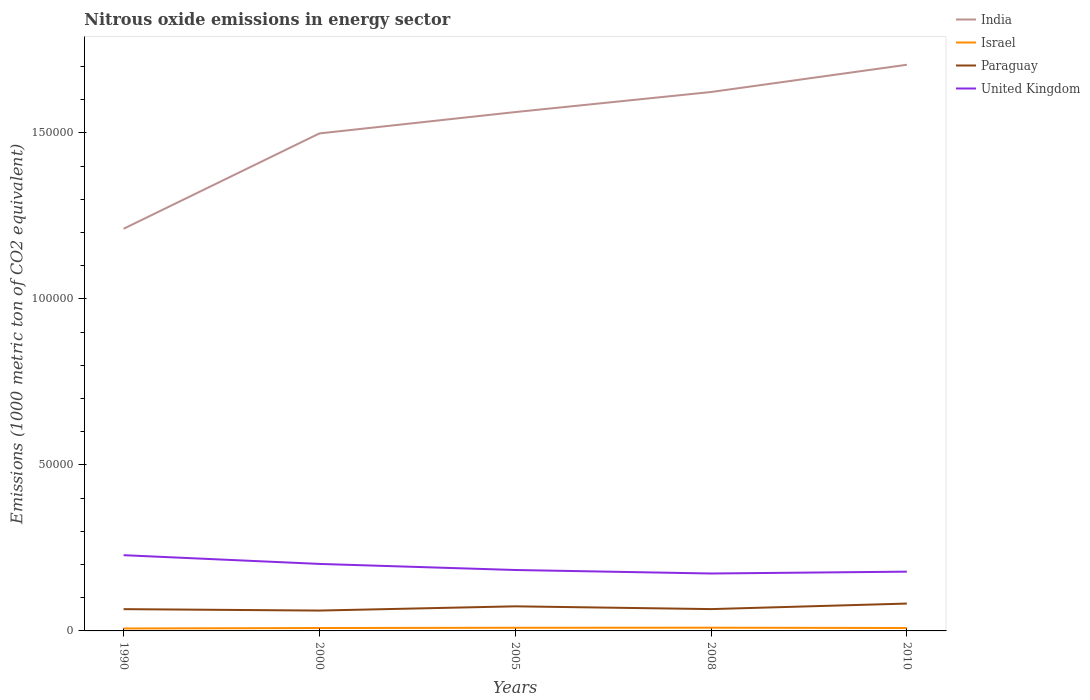Is the number of lines equal to the number of legend labels?
Your answer should be compact. Yes. Across all years, what is the maximum amount of nitrous oxide emitted in United Kingdom?
Ensure brevity in your answer.  1.73e+04. What is the total amount of nitrous oxide emitted in United Kingdom in the graph?
Offer a very short reply. 2887.8. What is the difference between the highest and the second highest amount of nitrous oxide emitted in Israel?
Offer a very short reply. 235.7. What is the difference between the highest and the lowest amount of nitrous oxide emitted in Israel?
Keep it short and to the point. 2. How many years are there in the graph?
Give a very brief answer. 5. Are the values on the major ticks of Y-axis written in scientific E-notation?
Your response must be concise. No. Does the graph contain any zero values?
Provide a succinct answer. No. Does the graph contain grids?
Your answer should be compact. No. How many legend labels are there?
Your answer should be compact. 4. What is the title of the graph?
Your response must be concise. Nitrous oxide emissions in energy sector. Does "Sweden" appear as one of the legend labels in the graph?
Your response must be concise. No. What is the label or title of the X-axis?
Keep it short and to the point. Years. What is the label or title of the Y-axis?
Ensure brevity in your answer.  Emissions (1000 metric ton of CO2 equivalent). What is the Emissions (1000 metric ton of CO2 equivalent) of India in 1990?
Ensure brevity in your answer.  1.21e+05. What is the Emissions (1000 metric ton of CO2 equivalent) of Israel in 1990?
Provide a succinct answer. 733.2. What is the Emissions (1000 metric ton of CO2 equivalent) in Paraguay in 1990?
Offer a terse response. 6561.2. What is the Emissions (1000 metric ton of CO2 equivalent) in United Kingdom in 1990?
Your response must be concise. 2.28e+04. What is the Emissions (1000 metric ton of CO2 equivalent) of India in 2000?
Your answer should be compact. 1.50e+05. What is the Emissions (1000 metric ton of CO2 equivalent) of Israel in 2000?
Keep it short and to the point. 875.7. What is the Emissions (1000 metric ton of CO2 equivalent) in Paraguay in 2000?
Your response must be concise. 6132.8. What is the Emissions (1000 metric ton of CO2 equivalent) in United Kingdom in 2000?
Your answer should be very brief. 2.02e+04. What is the Emissions (1000 metric ton of CO2 equivalent) in India in 2005?
Your answer should be compact. 1.56e+05. What is the Emissions (1000 metric ton of CO2 equivalent) in Israel in 2005?
Provide a succinct answer. 949.9. What is the Emissions (1000 metric ton of CO2 equivalent) of Paraguay in 2005?
Keep it short and to the point. 7407.7. What is the Emissions (1000 metric ton of CO2 equivalent) in United Kingdom in 2005?
Provide a short and direct response. 1.84e+04. What is the Emissions (1000 metric ton of CO2 equivalent) in India in 2008?
Ensure brevity in your answer.  1.62e+05. What is the Emissions (1000 metric ton of CO2 equivalent) in Israel in 2008?
Ensure brevity in your answer.  968.9. What is the Emissions (1000 metric ton of CO2 equivalent) of Paraguay in 2008?
Provide a succinct answer. 6573. What is the Emissions (1000 metric ton of CO2 equivalent) in United Kingdom in 2008?
Provide a succinct answer. 1.73e+04. What is the Emissions (1000 metric ton of CO2 equivalent) of India in 2010?
Ensure brevity in your answer.  1.71e+05. What is the Emissions (1000 metric ton of CO2 equivalent) in Israel in 2010?
Offer a very short reply. 881.8. What is the Emissions (1000 metric ton of CO2 equivalent) of Paraguay in 2010?
Your response must be concise. 8239.6. What is the Emissions (1000 metric ton of CO2 equivalent) in United Kingdom in 2010?
Provide a succinct answer. 1.79e+04. Across all years, what is the maximum Emissions (1000 metric ton of CO2 equivalent) of India?
Your answer should be compact. 1.71e+05. Across all years, what is the maximum Emissions (1000 metric ton of CO2 equivalent) of Israel?
Give a very brief answer. 968.9. Across all years, what is the maximum Emissions (1000 metric ton of CO2 equivalent) of Paraguay?
Provide a short and direct response. 8239.6. Across all years, what is the maximum Emissions (1000 metric ton of CO2 equivalent) of United Kingdom?
Your response must be concise. 2.28e+04. Across all years, what is the minimum Emissions (1000 metric ton of CO2 equivalent) in India?
Your answer should be very brief. 1.21e+05. Across all years, what is the minimum Emissions (1000 metric ton of CO2 equivalent) in Israel?
Ensure brevity in your answer.  733.2. Across all years, what is the minimum Emissions (1000 metric ton of CO2 equivalent) in Paraguay?
Keep it short and to the point. 6132.8. Across all years, what is the minimum Emissions (1000 metric ton of CO2 equivalent) in United Kingdom?
Your answer should be compact. 1.73e+04. What is the total Emissions (1000 metric ton of CO2 equivalent) in India in the graph?
Your answer should be very brief. 7.60e+05. What is the total Emissions (1000 metric ton of CO2 equivalent) in Israel in the graph?
Offer a terse response. 4409.5. What is the total Emissions (1000 metric ton of CO2 equivalent) in Paraguay in the graph?
Your response must be concise. 3.49e+04. What is the total Emissions (1000 metric ton of CO2 equivalent) of United Kingdom in the graph?
Offer a very short reply. 9.65e+04. What is the difference between the Emissions (1000 metric ton of CO2 equivalent) in India in 1990 and that in 2000?
Offer a very short reply. -2.87e+04. What is the difference between the Emissions (1000 metric ton of CO2 equivalent) in Israel in 1990 and that in 2000?
Ensure brevity in your answer.  -142.5. What is the difference between the Emissions (1000 metric ton of CO2 equivalent) in Paraguay in 1990 and that in 2000?
Offer a very short reply. 428.4. What is the difference between the Emissions (1000 metric ton of CO2 equivalent) in United Kingdom in 1990 and that in 2000?
Offer a terse response. 2628.9. What is the difference between the Emissions (1000 metric ton of CO2 equivalent) of India in 1990 and that in 2005?
Provide a succinct answer. -3.51e+04. What is the difference between the Emissions (1000 metric ton of CO2 equivalent) of Israel in 1990 and that in 2005?
Provide a short and direct response. -216.7. What is the difference between the Emissions (1000 metric ton of CO2 equivalent) in Paraguay in 1990 and that in 2005?
Keep it short and to the point. -846.5. What is the difference between the Emissions (1000 metric ton of CO2 equivalent) of United Kingdom in 1990 and that in 2005?
Ensure brevity in your answer.  4460.9. What is the difference between the Emissions (1000 metric ton of CO2 equivalent) in India in 1990 and that in 2008?
Make the answer very short. -4.12e+04. What is the difference between the Emissions (1000 metric ton of CO2 equivalent) in Israel in 1990 and that in 2008?
Your response must be concise. -235.7. What is the difference between the Emissions (1000 metric ton of CO2 equivalent) of United Kingdom in 1990 and that in 2008?
Your answer should be compact. 5516.7. What is the difference between the Emissions (1000 metric ton of CO2 equivalent) of India in 1990 and that in 2010?
Ensure brevity in your answer.  -4.94e+04. What is the difference between the Emissions (1000 metric ton of CO2 equivalent) of Israel in 1990 and that in 2010?
Keep it short and to the point. -148.6. What is the difference between the Emissions (1000 metric ton of CO2 equivalent) of Paraguay in 1990 and that in 2010?
Give a very brief answer. -1678.4. What is the difference between the Emissions (1000 metric ton of CO2 equivalent) in United Kingdom in 1990 and that in 2010?
Ensure brevity in your answer.  4962.2. What is the difference between the Emissions (1000 metric ton of CO2 equivalent) in India in 2000 and that in 2005?
Offer a very short reply. -6428.4. What is the difference between the Emissions (1000 metric ton of CO2 equivalent) of Israel in 2000 and that in 2005?
Provide a succinct answer. -74.2. What is the difference between the Emissions (1000 metric ton of CO2 equivalent) in Paraguay in 2000 and that in 2005?
Keep it short and to the point. -1274.9. What is the difference between the Emissions (1000 metric ton of CO2 equivalent) in United Kingdom in 2000 and that in 2005?
Your answer should be very brief. 1832. What is the difference between the Emissions (1000 metric ton of CO2 equivalent) of India in 2000 and that in 2008?
Provide a short and direct response. -1.25e+04. What is the difference between the Emissions (1000 metric ton of CO2 equivalent) of Israel in 2000 and that in 2008?
Provide a short and direct response. -93.2. What is the difference between the Emissions (1000 metric ton of CO2 equivalent) in Paraguay in 2000 and that in 2008?
Keep it short and to the point. -440.2. What is the difference between the Emissions (1000 metric ton of CO2 equivalent) of United Kingdom in 2000 and that in 2008?
Ensure brevity in your answer.  2887.8. What is the difference between the Emissions (1000 metric ton of CO2 equivalent) in India in 2000 and that in 2010?
Provide a short and direct response. -2.07e+04. What is the difference between the Emissions (1000 metric ton of CO2 equivalent) of Paraguay in 2000 and that in 2010?
Keep it short and to the point. -2106.8. What is the difference between the Emissions (1000 metric ton of CO2 equivalent) of United Kingdom in 2000 and that in 2010?
Give a very brief answer. 2333.3. What is the difference between the Emissions (1000 metric ton of CO2 equivalent) in India in 2005 and that in 2008?
Offer a very short reply. -6044.2. What is the difference between the Emissions (1000 metric ton of CO2 equivalent) in Paraguay in 2005 and that in 2008?
Your response must be concise. 834.7. What is the difference between the Emissions (1000 metric ton of CO2 equivalent) in United Kingdom in 2005 and that in 2008?
Keep it short and to the point. 1055.8. What is the difference between the Emissions (1000 metric ton of CO2 equivalent) in India in 2005 and that in 2010?
Make the answer very short. -1.43e+04. What is the difference between the Emissions (1000 metric ton of CO2 equivalent) in Israel in 2005 and that in 2010?
Your answer should be very brief. 68.1. What is the difference between the Emissions (1000 metric ton of CO2 equivalent) of Paraguay in 2005 and that in 2010?
Provide a succinct answer. -831.9. What is the difference between the Emissions (1000 metric ton of CO2 equivalent) in United Kingdom in 2005 and that in 2010?
Offer a very short reply. 501.3. What is the difference between the Emissions (1000 metric ton of CO2 equivalent) in India in 2008 and that in 2010?
Provide a short and direct response. -8207.6. What is the difference between the Emissions (1000 metric ton of CO2 equivalent) of Israel in 2008 and that in 2010?
Give a very brief answer. 87.1. What is the difference between the Emissions (1000 metric ton of CO2 equivalent) in Paraguay in 2008 and that in 2010?
Make the answer very short. -1666.6. What is the difference between the Emissions (1000 metric ton of CO2 equivalent) of United Kingdom in 2008 and that in 2010?
Keep it short and to the point. -554.5. What is the difference between the Emissions (1000 metric ton of CO2 equivalent) in India in 1990 and the Emissions (1000 metric ton of CO2 equivalent) in Israel in 2000?
Offer a very short reply. 1.20e+05. What is the difference between the Emissions (1000 metric ton of CO2 equivalent) in India in 1990 and the Emissions (1000 metric ton of CO2 equivalent) in Paraguay in 2000?
Your response must be concise. 1.15e+05. What is the difference between the Emissions (1000 metric ton of CO2 equivalent) of India in 1990 and the Emissions (1000 metric ton of CO2 equivalent) of United Kingdom in 2000?
Give a very brief answer. 1.01e+05. What is the difference between the Emissions (1000 metric ton of CO2 equivalent) of Israel in 1990 and the Emissions (1000 metric ton of CO2 equivalent) of Paraguay in 2000?
Your response must be concise. -5399.6. What is the difference between the Emissions (1000 metric ton of CO2 equivalent) in Israel in 1990 and the Emissions (1000 metric ton of CO2 equivalent) in United Kingdom in 2000?
Provide a short and direct response. -1.95e+04. What is the difference between the Emissions (1000 metric ton of CO2 equivalent) of Paraguay in 1990 and the Emissions (1000 metric ton of CO2 equivalent) of United Kingdom in 2000?
Provide a succinct answer. -1.36e+04. What is the difference between the Emissions (1000 metric ton of CO2 equivalent) in India in 1990 and the Emissions (1000 metric ton of CO2 equivalent) in Israel in 2005?
Your answer should be compact. 1.20e+05. What is the difference between the Emissions (1000 metric ton of CO2 equivalent) in India in 1990 and the Emissions (1000 metric ton of CO2 equivalent) in Paraguay in 2005?
Your answer should be very brief. 1.14e+05. What is the difference between the Emissions (1000 metric ton of CO2 equivalent) of India in 1990 and the Emissions (1000 metric ton of CO2 equivalent) of United Kingdom in 2005?
Your answer should be very brief. 1.03e+05. What is the difference between the Emissions (1000 metric ton of CO2 equivalent) in Israel in 1990 and the Emissions (1000 metric ton of CO2 equivalent) in Paraguay in 2005?
Offer a very short reply. -6674.5. What is the difference between the Emissions (1000 metric ton of CO2 equivalent) of Israel in 1990 and the Emissions (1000 metric ton of CO2 equivalent) of United Kingdom in 2005?
Your answer should be compact. -1.76e+04. What is the difference between the Emissions (1000 metric ton of CO2 equivalent) in Paraguay in 1990 and the Emissions (1000 metric ton of CO2 equivalent) in United Kingdom in 2005?
Offer a terse response. -1.18e+04. What is the difference between the Emissions (1000 metric ton of CO2 equivalent) in India in 1990 and the Emissions (1000 metric ton of CO2 equivalent) in Israel in 2008?
Provide a short and direct response. 1.20e+05. What is the difference between the Emissions (1000 metric ton of CO2 equivalent) in India in 1990 and the Emissions (1000 metric ton of CO2 equivalent) in Paraguay in 2008?
Your response must be concise. 1.15e+05. What is the difference between the Emissions (1000 metric ton of CO2 equivalent) in India in 1990 and the Emissions (1000 metric ton of CO2 equivalent) in United Kingdom in 2008?
Your answer should be very brief. 1.04e+05. What is the difference between the Emissions (1000 metric ton of CO2 equivalent) in Israel in 1990 and the Emissions (1000 metric ton of CO2 equivalent) in Paraguay in 2008?
Keep it short and to the point. -5839.8. What is the difference between the Emissions (1000 metric ton of CO2 equivalent) of Israel in 1990 and the Emissions (1000 metric ton of CO2 equivalent) of United Kingdom in 2008?
Make the answer very short. -1.66e+04. What is the difference between the Emissions (1000 metric ton of CO2 equivalent) of Paraguay in 1990 and the Emissions (1000 metric ton of CO2 equivalent) of United Kingdom in 2008?
Ensure brevity in your answer.  -1.07e+04. What is the difference between the Emissions (1000 metric ton of CO2 equivalent) of India in 1990 and the Emissions (1000 metric ton of CO2 equivalent) of Israel in 2010?
Your response must be concise. 1.20e+05. What is the difference between the Emissions (1000 metric ton of CO2 equivalent) of India in 1990 and the Emissions (1000 metric ton of CO2 equivalent) of Paraguay in 2010?
Provide a succinct answer. 1.13e+05. What is the difference between the Emissions (1000 metric ton of CO2 equivalent) of India in 1990 and the Emissions (1000 metric ton of CO2 equivalent) of United Kingdom in 2010?
Provide a succinct answer. 1.03e+05. What is the difference between the Emissions (1000 metric ton of CO2 equivalent) in Israel in 1990 and the Emissions (1000 metric ton of CO2 equivalent) in Paraguay in 2010?
Provide a short and direct response. -7506.4. What is the difference between the Emissions (1000 metric ton of CO2 equivalent) in Israel in 1990 and the Emissions (1000 metric ton of CO2 equivalent) in United Kingdom in 2010?
Your answer should be compact. -1.71e+04. What is the difference between the Emissions (1000 metric ton of CO2 equivalent) of Paraguay in 1990 and the Emissions (1000 metric ton of CO2 equivalent) of United Kingdom in 2010?
Your answer should be very brief. -1.13e+04. What is the difference between the Emissions (1000 metric ton of CO2 equivalent) of India in 2000 and the Emissions (1000 metric ton of CO2 equivalent) of Israel in 2005?
Your response must be concise. 1.49e+05. What is the difference between the Emissions (1000 metric ton of CO2 equivalent) of India in 2000 and the Emissions (1000 metric ton of CO2 equivalent) of Paraguay in 2005?
Make the answer very short. 1.42e+05. What is the difference between the Emissions (1000 metric ton of CO2 equivalent) in India in 2000 and the Emissions (1000 metric ton of CO2 equivalent) in United Kingdom in 2005?
Keep it short and to the point. 1.32e+05. What is the difference between the Emissions (1000 metric ton of CO2 equivalent) in Israel in 2000 and the Emissions (1000 metric ton of CO2 equivalent) in Paraguay in 2005?
Ensure brevity in your answer.  -6532. What is the difference between the Emissions (1000 metric ton of CO2 equivalent) in Israel in 2000 and the Emissions (1000 metric ton of CO2 equivalent) in United Kingdom in 2005?
Your answer should be compact. -1.75e+04. What is the difference between the Emissions (1000 metric ton of CO2 equivalent) of Paraguay in 2000 and the Emissions (1000 metric ton of CO2 equivalent) of United Kingdom in 2005?
Provide a succinct answer. -1.22e+04. What is the difference between the Emissions (1000 metric ton of CO2 equivalent) of India in 2000 and the Emissions (1000 metric ton of CO2 equivalent) of Israel in 2008?
Your answer should be compact. 1.49e+05. What is the difference between the Emissions (1000 metric ton of CO2 equivalent) of India in 2000 and the Emissions (1000 metric ton of CO2 equivalent) of Paraguay in 2008?
Offer a terse response. 1.43e+05. What is the difference between the Emissions (1000 metric ton of CO2 equivalent) in India in 2000 and the Emissions (1000 metric ton of CO2 equivalent) in United Kingdom in 2008?
Your response must be concise. 1.33e+05. What is the difference between the Emissions (1000 metric ton of CO2 equivalent) in Israel in 2000 and the Emissions (1000 metric ton of CO2 equivalent) in Paraguay in 2008?
Your response must be concise. -5697.3. What is the difference between the Emissions (1000 metric ton of CO2 equivalent) in Israel in 2000 and the Emissions (1000 metric ton of CO2 equivalent) in United Kingdom in 2008?
Provide a succinct answer. -1.64e+04. What is the difference between the Emissions (1000 metric ton of CO2 equivalent) in Paraguay in 2000 and the Emissions (1000 metric ton of CO2 equivalent) in United Kingdom in 2008?
Your response must be concise. -1.12e+04. What is the difference between the Emissions (1000 metric ton of CO2 equivalent) of India in 2000 and the Emissions (1000 metric ton of CO2 equivalent) of Israel in 2010?
Your response must be concise. 1.49e+05. What is the difference between the Emissions (1000 metric ton of CO2 equivalent) of India in 2000 and the Emissions (1000 metric ton of CO2 equivalent) of Paraguay in 2010?
Keep it short and to the point. 1.42e+05. What is the difference between the Emissions (1000 metric ton of CO2 equivalent) in India in 2000 and the Emissions (1000 metric ton of CO2 equivalent) in United Kingdom in 2010?
Your answer should be very brief. 1.32e+05. What is the difference between the Emissions (1000 metric ton of CO2 equivalent) of Israel in 2000 and the Emissions (1000 metric ton of CO2 equivalent) of Paraguay in 2010?
Offer a very short reply. -7363.9. What is the difference between the Emissions (1000 metric ton of CO2 equivalent) in Israel in 2000 and the Emissions (1000 metric ton of CO2 equivalent) in United Kingdom in 2010?
Provide a succinct answer. -1.70e+04. What is the difference between the Emissions (1000 metric ton of CO2 equivalent) in Paraguay in 2000 and the Emissions (1000 metric ton of CO2 equivalent) in United Kingdom in 2010?
Keep it short and to the point. -1.17e+04. What is the difference between the Emissions (1000 metric ton of CO2 equivalent) in India in 2005 and the Emissions (1000 metric ton of CO2 equivalent) in Israel in 2008?
Your answer should be very brief. 1.55e+05. What is the difference between the Emissions (1000 metric ton of CO2 equivalent) of India in 2005 and the Emissions (1000 metric ton of CO2 equivalent) of Paraguay in 2008?
Your answer should be compact. 1.50e+05. What is the difference between the Emissions (1000 metric ton of CO2 equivalent) in India in 2005 and the Emissions (1000 metric ton of CO2 equivalent) in United Kingdom in 2008?
Your response must be concise. 1.39e+05. What is the difference between the Emissions (1000 metric ton of CO2 equivalent) of Israel in 2005 and the Emissions (1000 metric ton of CO2 equivalent) of Paraguay in 2008?
Keep it short and to the point. -5623.1. What is the difference between the Emissions (1000 metric ton of CO2 equivalent) of Israel in 2005 and the Emissions (1000 metric ton of CO2 equivalent) of United Kingdom in 2008?
Make the answer very short. -1.63e+04. What is the difference between the Emissions (1000 metric ton of CO2 equivalent) of Paraguay in 2005 and the Emissions (1000 metric ton of CO2 equivalent) of United Kingdom in 2008?
Make the answer very short. -9889.5. What is the difference between the Emissions (1000 metric ton of CO2 equivalent) of India in 2005 and the Emissions (1000 metric ton of CO2 equivalent) of Israel in 2010?
Your answer should be very brief. 1.55e+05. What is the difference between the Emissions (1000 metric ton of CO2 equivalent) in India in 2005 and the Emissions (1000 metric ton of CO2 equivalent) in Paraguay in 2010?
Provide a succinct answer. 1.48e+05. What is the difference between the Emissions (1000 metric ton of CO2 equivalent) of India in 2005 and the Emissions (1000 metric ton of CO2 equivalent) of United Kingdom in 2010?
Your answer should be compact. 1.38e+05. What is the difference between the Emissions (1000 metric ton of CO2 equivalent) in Israel in 2005 and the Emissions (1000 metric ton of CO2 equivalent) in Paraguay in 2010?
Provide a succinct answer. -7289.7. What is the difference between the Emissions (1000 metric ton of CO2 equivalent) in Israel in 2005 and the Emissions (1000 metric ton of CO2 equivalent) in United Kingdom in 2010?
Give a very brief answer. -1.69e+04. What is the difference between the Emissions (1000 metric ton of CO2 equivalent) of Paraguay in 2005 and the Emissions (1000 metric ton of CO2 equivalent) of United Kingdom in 2010?
Your answer should be compact. -1.04e+04. What is the difference between the Emissions (1000 metric ton of CO2 equivalent) in India in 2008 and the Emissions (1000 metric ton of CO2 equivalent) in Israel in 2010?
Ensure brevity in your answer.  1.61e+05. What is the difference between the Emissions (1000 metric ton of CO2 equivalent) in India in 2008 and the Emissions (1000 metric ton of CO2 equivalent) in Paraguay in 2010?
Ensure brevity in your answer.  1.54e+05. What is the difference between the Emissions (1000 metric ton of CO2 equivalent) in India in 2008 and the Emissions (1000 metric ton of CO2 equivalent) in United Kingdom in 2010?
Your response must be concise. 1.44e+05. What is the difference between the Emissions (1000 metric ton of CO2 equivalent) of Israel in 2008 and the Emissions (1000 metric ton of CO2 equivalent) of Paraguay in 2010?
Offer a terse response. -7270.7. What is the difference between the Emissions (1000 metric ton of CO2 equivalent) of Israel in 2008 and the Emissions (1000 metric ton of CO2 equivalent) of United Kingdom in 2010?
Your response must be concise. -1.69e+04. What is the difference between the Emissions (1000 metric ton of CO2 equivalent) in Paraguay in 2008 and the Emissions (1000 metric ton of CO2 equivalent) in United Kingdom in 2010?
Provide a short and direct response. -1.13e+04. What is the average Emissions (1000 metric ton of CO2 equivalent) of India per year?
Provide a short and direct response. 1.52e+05. What is the average Emissions (1000 metric ton of CO2 equivalent) of Israel per year?
Give a very brief answer. 881.9. What is the average Emissions (1000 metric ton of CO2 equivalent) in Paraguay per year?
Your answer should be very brief. 6982.86. What is the average Emissions (1000 metric ton of CO2 equivalent) in United Kingdom per year?
Your answer should be very brief. 1.93e+04. In the year 1990, what is the difference between the Emissions (1000 metric ton of CO2 equivalent) of India and Emissions (1000 metric ton of CO2 equivalent) of Israel?
Keep it short and to the point. 1.20e+05. In the year 1990, what is the difference between the Emissions (1000 metric ton of CO2 equivalent) of India and Emissions (1000 metric ton of CO2 equivalent) of Paraguay?
Ensure brevity in your answer.  1.15e+05. In the year 1990, what is the difference between the Emissions (1000 metric ton of CO2 equivalent) in India and Emissions (1000 metric ton of CO2 equivalent) in United Kingdom?
Keep it short and to the point. 9.83e+04. In the year 1990, what is the difference between the Emissions (1000 metric ton of CO2 equivalent) in Israel and Emissions (1000 metric ton of CO2 equivalent) in Paraguay?
Provide a succinct answer. -5828. In the year 1990, what is the difference between the Emissions (1000 metric ton of CO2 equivalent) in Israel and Emissions (1000 metric ton of CO2 equivalent) in United Kingdom?
Provide a short and direct response. -2.21e+04. In the year 1990, what is the difference between the Emissions (1000 metric ton of CO2 equivalent) of Paraguay and Emissions (1000 metric ton of CO2 equivalent) of United Kingdom?
Provide a succinct answer. -1.63e+04. In the year 2000, what is the difference between the Emissions (1000 metric ton of CO2 equivalent) of India and Emissions (1000 metric ton of CO2 equivalent) of Israel?
Provide a short and direct response. 1.49e+05. In the year 2000, what is the difference between the Emissions (1000 metric ton of CO2 equivalent) in India and Emissions (1000 metric ton of CO2 equivalent) in Paraguay?
Provide a succinct answer. 1.44e+05. In the year 2000, what is the difference between the Emissions (1000 metric ton of CO2 equivalent) of India and Emissions (1000 metric ton of CO2 equivalent) of United Kingdom?
Keep it short and to the point. 1.30e+05. In the year 2000, what is the difference between the Emissions (1000 metric ton of CO2 equivalent) in Israel and Emissions (1000 metric ton of CO2 equivalent) in Paraguay?
Offer a terse response. -5257.1. In the year 2000, what is the difference between the Emissions (1000 metric ton of CO2 equivalent) in Israel and Emissions (1000 metric ton of CO2 equivalent) in United Kingdom?
Offer a very short reply. -1.93e+04. In the year 2000, what is the difference between the Emissions (1000 metric ton of CO2 equivalent) in Paraguay and Emissions (1000 metric ton of CO2 equivalent) in United Kingdom?
Offer a very short reply. -1.41e+04. In the year 2005, what is the difference between the Emissions (1000 metric ton of CO2 equivalent) of India and Emissions (1000 metric ton of CO2 equivalent) of Israel?
Offer a very short reply. 1.55e+05. In the year 2005, what is the difference between the Emissions (1000 metric ton of CO2 equivalent) in India and Emissions (1000 metric ton of CO2 equivalent) in Paraguay?
Ensure brevity in your answer.  1.49e+05. In the year 2005, what is the difference between the Emissions (1000 metric ton of CO2 equivalent) of India and Emissions (1000 metric ton of CO2 equivalent) of United Kingdom?
Keep it short and to the point. 1.38e+05. In the year 2005, what is the difference between the Emissions (1000 metric ton of CO2 equivalent) in Israel and Emissions (1000 metric ton of CO2 equivalent) in Paraguay?
Keep it short and to the point. -6457.8. In the year 2005, what is the difference between the Emissions (1000 metric ton of CO2 equivalent) in Israel and Emissions (1000 metric ton of CO2 equivalent) in United Kingdom?
Your response must be concise. -1.74e+04. In the year 2005, what is the difference between the Emissions (1000 metric ton of CO2 equivalent) of Paraguay and Emissions (1000 metric ton of CO2 equivalent) of United Kingdom?
Your answer should be compact. -1.09e+04. In the year 2008, what is the difference between the Emissions (1000 metric ton of CO2 equivalent) of India and Emissions (1000 metric ton of CO2 equivalent) of Israel?
Offer a very short reply. 1.61e+05. In the year 2008, what is the difference between the Emissions (1000 metric ton of CO2 equivalent) of India and Emissions (1000 metric ton of CO2 equivalent) of Paraguay?
Keep it short and to the point. 1.56e+05. In the year 2008, what is the difference between the Emissions (1000 metric ton of CO2 equivalent) of India and Emissions (1000 metric ton of CO2 equivalent) of United Kingdom?
Ensure brevity in your answer.  1.45e+05. In the year 2008, what is the difference between the Emissions (1000 metric ton of CO2 equivalent) in Israel and Emissions (1000 metric ton of CO2 equivalent) in Paraguay?
Your answer should be very brief. -5604.1. In the year 2008, what is the difference between the Emissions (1000 metric ton of CO2 equivalent) in Israel and Emissions (1000 metric ton of CO2 equivalent) in United Kingdom?
Your response must be concise. -1.63e+04. In the year 2008, what is the difference between the Emissions (1000 metric ton of CO2 equivalent) in Paraguay and Emissions (1000 metric ton of CO2 equivalent) in United Kingdom?
Your answer should be very brief. -1.07e+04. In the year 2010, what is the difference between the Emissions (1000 metric ton of CO2 equivalent) of India and Emissions (1000 metric ton of CO2 equivalent) of Israel?
Make the answer very short. 1.70e+05. In the year 2010, what is the difference between the Emissions (1000 metric ton of CO2 equivalent) in India and Emissions (1000 metric ton of CO2 equivalent) in Paraguay?
Make the answer very short. 1.62e+05. In the year 2010, what is the difference between the Emissions (1000 metric ton of CO2 equivalent) in India and Emissions (1000 metric ton of CO2 equivalent) in United Kingdom?
Offer a very short reply. 1.53e+05. In the year 2010, what is the difference between the Emissions (1000 metric ton of CO2 equivalent) in Israel and Emissions (1000 metric ton of CO2 equivalent) in Paraguay?
Your answer should be very brief. -7357.8. In the year 2010, what is the difference between the Emissions (1000 metric ton of CO2 equivalent) of Israel and Emissions (1000 metric ton of CO2 equivalent) of United Kingdom?
Your response must be concise. -1.70e+04. In the year 2010, what is the difference between the Emissions (1000 metric ton of CO2 equivalent) of Paraguay and Emissions (1000 metric ton of CO2 equivalent) of United Kingdom?
Give a very brief answer. -9612.1. What is the ratio of the Emissions (1000 metric ton of CO2 equivalent) in India in 1990 to that in 2000?
Keep it short and to the point. 0.81. What is the ratio of the Emissions (1000 metric ton of CO2 equivalent) in Israel in 1990 to that in 2000?
Your answer should be very brief. 0.84. What is the ratio of the Emissions (1000 metric ton of CO2 equivalent) in Paraguay in 1990 to that in 2000?
Keep it short and to the point. 1.07. What is the ratio of the Emissions (1000 metric ton of CO2 equivalent) in United Kingdom in 1990 to that in 2000?
Your answer should be very brief. 1.13. What is the ratio of the Emissions (1000 metric ton of CO2 equivalent) of India in 1990 to that in 2005?
Ensure brevity in your answer.  0.78. What is the ratio of the Emissions (1000 metric ton of CO2 equivalent) in Israel in 1990 to that in 2005?
Offer a very short reply. 0.77. What is the ratio of the Emissions (1000 metric ton of CO2 equivalent) in Paraguay in 1990 to that in 2005?
Your answer should be compact. 0.89. What is the ratio of the Emissions (1000 metric ton of CO2 equivalent) in United Kingdom in 1990 to that in 2005?
Provide a succinct answer. 1.24. What is the ratio of the Emissions (1000 metric ton of CO2 equivalent) of India in 1990 to that in 2008?
Ensure brevity in your answer.  0.75. What is the ratio of the Emissions (1000 metric ton of CO2 equivalent) in Israel in 1990 to that in 2008?
Your answer should be compact. 0.76. What is the ratio of the Emissions (1000 metric ton of CO2 equivalent) of Paraguay in 1990 to that in 2008?
Keep it short and to the point. 1. What is the ratio of the Emissions (1000 metric ton of CO2 equivalent) in United Kingdom in 1990 to that in 2008?
Offer a very short reply. 1.32. What is the ratio of the Emissions (1000 metric ton of CO2 equivalent) in India in 1990 to that in 2010?
Offer a very short reply. 0.71. What is the ratio of the Emissions (1000 metric ton of CO2 equivalent) in Israel in 1990 to that in 2010?
Your answer should be compact. 0.83. What is the ratio of the Emissions (1000 metric ton of CO2 equivalent) of Paraguay in 1990 to that in 2010?
Provide a short and direct response. 0.8. What is the ratio of the Emissions (1000 metric ton of CO2 equivalent) of United Kingdom in 1990 to that in 2010?
Offer a very short reply. 1.28. What is the ratio of the Emissions (1000 metric ton of CO2 equivalent) of India in 2000 to that in 2005?
Give a very brief answer. 0.96. What is the ratio of the Emissions (1000 metric ton of CO2 equivalent) in Israel in 2000 to that in 2005?
Your response must be concise. 0.92. What is the ratio of the Emissions (1000 metric ton of CO2 equivalent) in Paraguay in 2000 to that in 2005?
Provide a short and direct response. 0.83. What is the ratio of the Emissions (1000 metric ton of CO2 equivalent) in United Kingdom in 2000 to that in 2005?
Provide a short and direct response. 1.1. What is the ratio of the Emissions (1000 metric ton of CO2 equivalent) in India in 2000 to that in 2008?
Ensure brevity in your answer.  0.92. What is the ratio of the Emissions (1000 metric ton of CO2 equivalent) in Israel in 2000 to that in 2008?
Provide a short and direct response. 0.9. What is the ratio of the Emissions (1000 metric ton of CO2 equivalent) in Paraguay in 2000 to that in 2008?
Your response must be concise. 0.93. What is the ratio of the Emissions (1000 metric ton of CO2 equivalent) of United Kingdom in 2000 to that in 2008?
Offer a terse response. 1.17. What is the ratio of the Emissions (1000 metric ton of CO2 equivalent) of India in 2000 to that in 2010?
Your answer should be compact. 0.88. What is the ratio of the Emissions (1000 metric ton of CO2 equivalent) of Paraguay in 2000 to that in 2010?
Your response must be concise. 0.74. What is the ratio of the Emissions (1000 metric ton of CO2 equivalent) in United Kingdom in 2000 to that in 2010?
Offer a terse response. 1.13. What is the ratio of the Emissions (1000 metric ton of CO2 equivalent) in India in 2005 to that in 2008?
Offer a terse response. 0.96. What is the ratio of the Emissions (1000 metric ton of CO2 equivalent) in Israel in 2005 to that in 2008?
Keep it short and to the point. 0.98. What is the ratio of the Emissions (1000 metric ton of CO2 equivalent) in Paraguay in 2005 to that in 2008?
Offer a terse response. 1.13. What is the ratio of the Emissions (1000 metric ton of CO2 equivalent) of United Kingdom in 2005 to that in 2008?
Provide a succinct answer. 1.06. What is the ratio of the Emissions (1000 metric ton of CO2 equivalent) of India in 2005 to that in 2010?
Provide a succinct answer. 0.92. What is the ratio of the Emissions (1000 metric ton of CO2 equivalent) of Israel in 2005 to that in 2010?
Your response must be concise. 1.08. What is the ratio of the Emissions (1000 metric ton of CO2 equivalent) of Paraguay in 2005 to that in 2010?
Offer a very short reply. 0.9. What is the ratio of the Emissions (1000 metric ton of CO2 equivalent) in United Kingdom in 2005 to that in 2010?
Offer a very short reply. 1.03. What is the ratio of the Emissions (1000 metric ton of CO2 equivalent) of India in 2008 to that in 2010?
Make the answer very short. 0.95. What is the ratio of the Emissions (1000 metric ton of CO2 equivalent) in Israel in 2008 to that in 2010?
Offer a very short reply. 1.1. What is the ratio of the Emissions (1000 metric ton of CO2 equivalent) of Paraguay in 2008 to that in 2010?
Offer a terse response. 0.8. What is the ratio of the Emissions (1000 metric ton of CO2 equivalent) of United Kingdom in 2008 to that in 2010?
Offer a terse response. 0.97. What is the difference between the highest and the second highest Emissions (1000 metric ton of CO2 equivalent) in India?
Your response must be concise. 8207.6. What is the difference between the highest and the second highest Emissions (1000 metric ton of CO2 equivalent) of Paraguay?
Your answer should be very brief. 831.9. What is the difference between the highest and the second highest Emissions (1000 metric ton of CO2 equivalent) in United Kingdom?
Provide a succinct answer. 2628.9. What is the difference between the highest and the lowest Emissions (1000 metric ton of CO2 equivalent) of India?
Your answer should be very brief. 4.94e+04. What is the difference between the highest and the lowest Emissions (1000 metric ton of CO2 equivalent) in Israel?
Provide a succinct answer. 235.7. What is the difference between the highest and the lowest Emissions (1000 metric ton of CO2 equivalent) in Paraguay?
Provide a short and direct response. 2106.8. What is the difference between the highest and the lowest Emissions (1000 metric ton of CO2 equivalent) of United Kingdom?
Offer a terse response. 5516.7. 